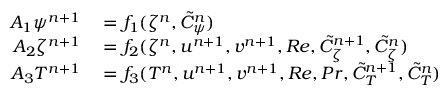<formula> <loc_0><loc_0><loc_500><loc_500>\begin{array} { r l } { A _ { 1 } \psi ^ { n + 1 } } & = f _ { 1 } ( \zeta ^ { n } , \tilde { C } _ { \psi } ^ { n } ) } \\ { A _ { 2 } \zeta ^ { n + 1 } } & = f _ { 2 } ( \zeta ^ { n } , u ^ { n + 1 } , v ^ { n + 1 } , R e , \tilde { C } _ { \zeta } ^ { n + 1 } , \tilde { C } _ { \zeta } ^ { n } ) } \\ { A _ { 3 } T ^ { n + 1 } } & = f _ { 3 } ( T ^ { n } , u ^ { n + 1 } , v ^ { n + 1 } , R e , P r , \tilde { C } _ { T } ^ { n + 1 } , \tilde { C } _ { T } ^ { n } ) } \end{array}</formula> 